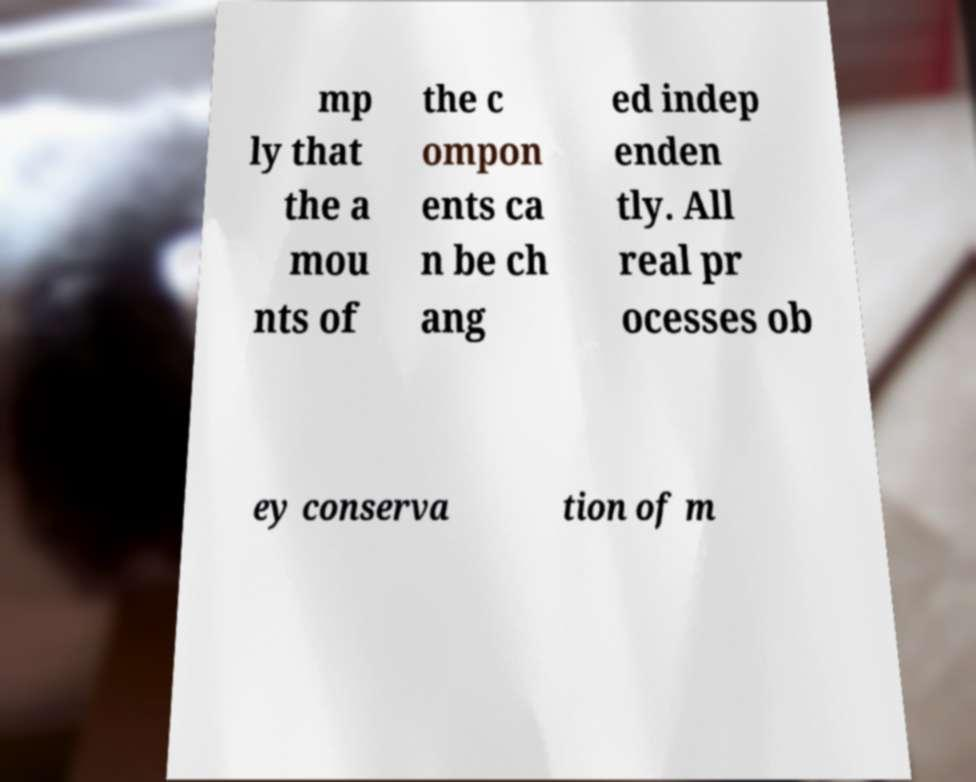Please read and relay the text visible in this image. What does it say? mp ly that the a mou nts of the c ompon ents ca n be ch ang ed indep enden tly. All real pr ocesses ob ey conserva tion of m 